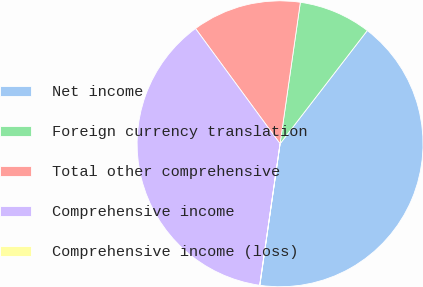Convert chart. <chart><loc_0><loc_0><loc_500><loc_500><pie_chart><fcel>Net income<fcel>Foreign currency translation<fcel>Total other comprehensive<fcel>Comprehensive income<fcel>Comprehensive income (loss)<nl><fcel>41.81%<fcel>8.18%<fcel>12.34%<fcel>37.65%<fcel>0.02%<nl></chart> 